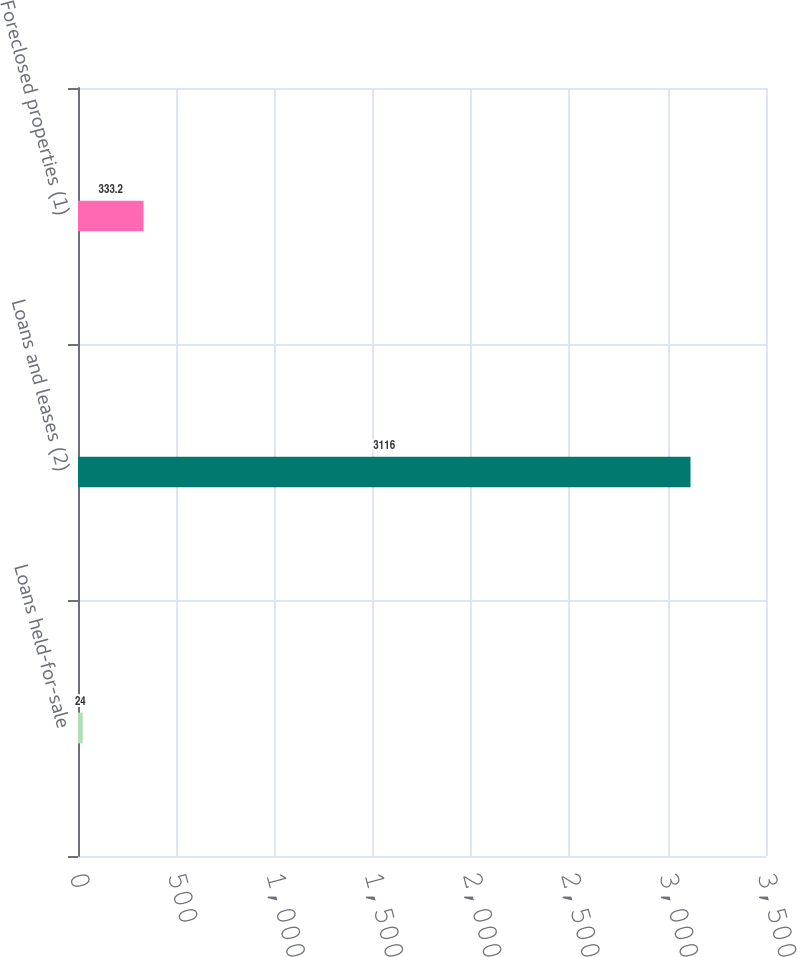<chart> <loc_0><loc_0><loc_500><loc_500><bar_chart><fcel>Loans held-for-sale<fcel>Loans and leases (2)<fcel>Foreclosed properties (1)<nl><fcel>24<fcel>3116<fcel>333.2<nl></chart> 